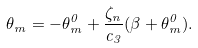Convert formula to latex. <formula><loc_0><loc_0><loc_500><loc_500>\theta _ { m } = - \theta ^ { 0 } _ { m } + \frac { \zeta _ { n } } { c _ { 3 } } ( \beta + \theta ^ { 0 } _ { m } ) .</formula> 